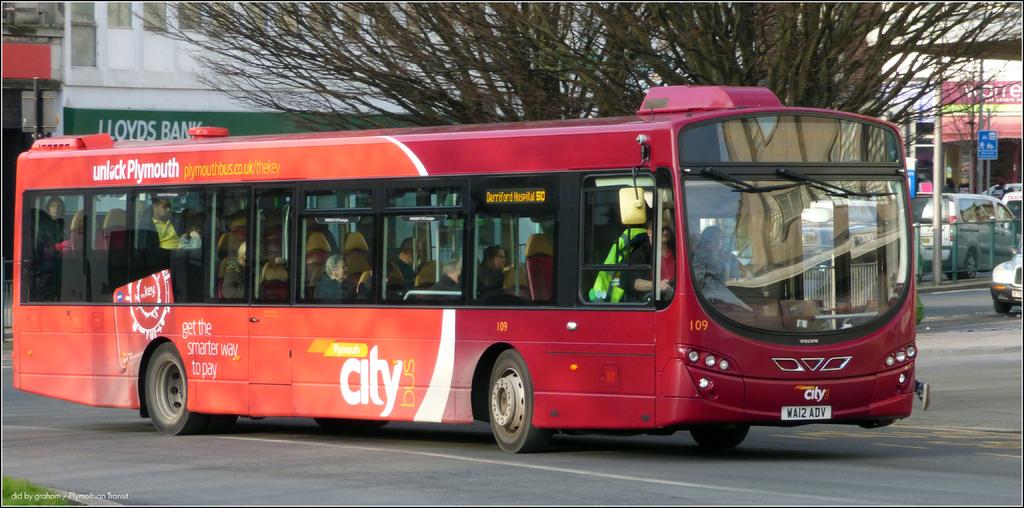What is the buses number?
Offer a terse response. 109. Wai2 adv are the number of buses?
Provide a short and direct response. 109. 